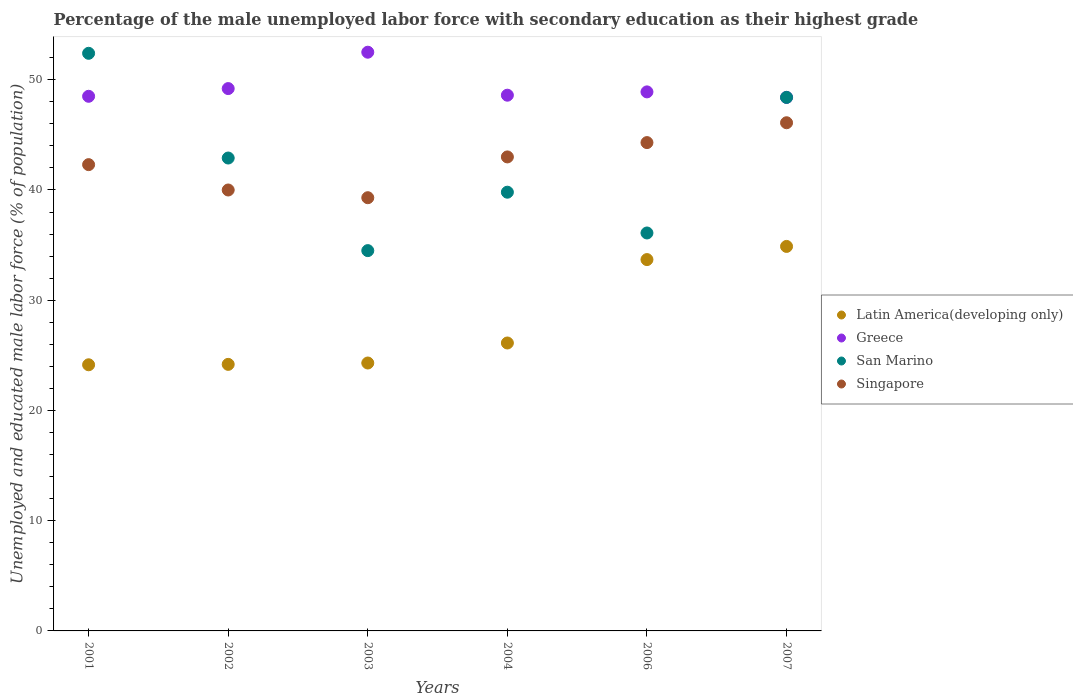Is the number of dotlines equal to the number of legend labels?
Provide a succinct answer. Yes. What is the percentage of the unemployed male labor force with secondary education in Latin America(developing only) in 2006?
Keep it short and to the point. 33.69. Across all years, what is the maximum percentage of the unemployed male labor force with secondary education in San Marino?
Keep it short and to the point. 52.4. Across all years, what is the minimum percentage of the unemployed male labor force with secondary education in Greece?
Your answer should be compact. 48.4. In which year was the percentage of the unemployed male labor force with secondary education in Singapore minimum?
Offer a terse response. 2003. What is the total percentage of the unemployed male labor force with secondary education in Latin America(developing only) in the graph?
Give a very brief answer. 167.32. What is the difference between the percentage of the unemployed male labor force with secondary education in San Marino in 2003 and that in 2007?
Your answer should be compact. -13.9. What is the difference between the percentage of the unemployed male labor force with secondary education in Singapore in 2006 and the percentage of the unemployed male labor force with secondary education in Greece in 2002?
Offer a terse response. -4.9. What is the average percentage of the unemployed male labor force with secondary education in San Marino per year?
Offer a terse response. 42.35. In the year 2007, what is the difference between the percentage of the unemployed male labor force with secondary education in Singapore and percentage of the unemployed male labor force with secondary education in San Marino?
Offer a very short reply. -2.3. What is the ratio of the percentage of the unemployed male labor force with secondary education in San Marino in 2003 to that in 2004?
Provide a short and direct response. 0.87. Is the percentage of the unemployed male labor force with secondary education in Singapore in 2004 less than that in 2007?
Your answer should be very brief. Yes. What is the difference between the highest and the second highest percentage of the unemployed male labor force with secondary education in Greece?
Your response must be concise. 3.3. What is the difference between the highest and the lowest percentage of the unemployed male labor force with secondary education in Latin America(developing only)?
Give a very brief answer. 10.74. In how many years, is the percentage of the unemployed male labor force with secondary education in Singapore greater than the average percentage of the unemployed male labor force with secondary education in Singapore taken over all years?
Your response must be concise. 3. Is the sum of the percentage of the unemployed male labor force with secondary education in Singapore in 2001 and 2006 greater than the maximum percentage of the unemployed male labor force with secondary education in Greece across all years?
Your answer should be compact. Yes. Is it the case that in every year, the sum of the percentage of the unemployed male labor force with secondary education in San Marino and percentage of the unemployed male labor force with secondary education in Singapore  is greater than the sum of percentage of the unemployed male labor force with secondary education in Latin America(developing only) and percentage of the unemployed male labor force with secondary education in Greece?
Your response must be concise. No. Is the percentage of the unemployed male labor force with secondary education in Singapore strictly greater than the percentage of the unemployed male labor force with secondary education in Greece over the years?
Keep it short and to the point. No. How many dotlines are there?
Your response must be concise. 4. Are the values on the major ticks of Y-axis written in scientific E-notation?
Your answer should be compact. No. Does the graph contain any zero values?
Your answer should be compact. No. Where does the legend appear in the graph?
Your answer should be very brief. Center right. How are the legend labels stacked?
Your answer should be very brief. Vertical. What is the title of the graph?
Your answer should be very brief. Percentage of the male unemployed labor force with secondary education as their highest grade. What is the label or title of the X-axis?
Offer a very short reply. Years. What is the label or title of the Y-axis?
Give a very brief answer. Unemployed and educated male labor force (% of population). What is the Unemployed and educated male labor force (% of population) of Latin America(developing only) in 2001?
Give a very brief answer. 24.14. What is the Unemployed and educated male labor force (% of population) of Greece in 2001?
Provide a short and direct response. 48.5. What is the Unemployed and educated male labor force (% of population) in San Marino in 2001?
Offer a very short reply. 52.4. What is the Unemployed and educated male labor force (% of population) of Singapore in 2001?
Provide a short and direct response. 42.3. What is the Unemployed and educated male labor force (% of population) of Latin America(developing only) in 2002?
Your answer should be compact. 24.18. What is the Unemployed and educated male labor force (% of population) in Greece in 2002?
Your answer should be very brief. 49.2. What is the Unemployed and educated male labor force (% of population) of San Marino in 2002?
Provide a succinct answer. 42.9. What is the Unemployed and educated male labor force (% of population) in Singapore in 2002?
Offer a terse response. 40. What is the Unemployed and educated male labor force (% of population) in Latin America(developing only) in 2003?
Your response must be concise. 24.3. What is the Unemployed and educated male labor force (% of population) in Greece in 2003?
Keep it short and to the point. 52.5. What is the Unemployed and educated male labor force (% of population) of San Marino in 2003?
Keep it short and to the point. 34.5. What is the Unemployed and educated male labor force (% of population) of Singapore in 2003?
Ensure brevity in your answer.  39.3. What is the Unemployed and educated male labor force (% of population) in Latin America(developing only) in 2004?
Ensure brevity in your answer.  26.12. What is the Unemployed and educated male labor force (% of population) in Greece in 2004?
Keep it short and to the point. 48.6. What is the Unemployed and educated male labor force (% of population) of San Marino in 2004?
Ensure brevity in your answer.  39.8. What is the Unemployed and educated male labor force (% of population) in Singapore in 2004?
Provide a succinct answer. 43. What is the Unemployed and educated male labor force (% of population) in Latin America(developing only) in 2006?
Offer a terse response. 33.69. What is the Unemployed and educated male labor force (% of population) of Greece in 2006?
Make the answer very short. 48.9. What is the Unemployed and educated male labor force (% of population) in San Marino in 2006?
Your answer should be very brief. 36.1. What is the Unemployed and educated male labor force (% of population) of Singapore in 2006?
Ensure brevity in your answer.  44.3. What is the Unemployed and educated male labor force (% of population) of Latin America(developing only) in 2007?
Offer a terse response. 34.88. What is the Unemployed and educated male labor force (% of population) of Greece in 2007?
Keep it short and to the point. 48.4. What is the Unemployed and educated male labor force (% of population) of San Marino in 2007?
Provide a short and direct response. 48.4. What is the Unemployed and educated male labor force (% of population) in Singapore in 2007?
Your response must be concise. 46.1. Across all years, what is the maximum Unemployed and educated male labor force (% of population) of Latin America(developing only)?
Keep it short and to the point. 34.88. Across all years, what is the maximum Unemployed and educated male labor force (% of population) in Greece?
Keep it short and to the point. 52.5. Across all years, what is the maximum Unemployed and educated male labor force (% of population) in San Marino?
Your response must be concise. 52.4. Across all years, what is the maximum Unemployed and educated male labor force (% of population) of Singapore?
Ensure brevity in your answer.  46.1. Across all years, what is the minimum Unemployed and educated male labor force (% of population) in Latin America(developing only)?
Your answer should be compact. 24.14. Across all years, what is the minimum Unemployed and educated male labor force (% of population) of Greece?
Your response must be concise. 48.4. Across all years, what is the minimum Unemployed and educated male labor force (% of population) of San Marino?
Your answer should be very brief. 34.5. Across all years, what is the minimum Unemployed and educated male labor force (% of population) of Singapore?
Offer a very short reply. 39.3. What is the total Unemployed and educated male labor force (% of population) in Latin America(developing only) in the graph?
Keep it short and to the point. 167.32. What is the total Unemployed and educated male labor force (% of population) of Greece in the graph?
Your response must be concise. 296.1. What is the total Unemployed and educated male labor force (% of population) in San Marino in the graph?
Your response must be concise. 254.1. What is the total Unemployed and educated male labor force (% of population) in Singapore in the graph?
Your answer should be compact. 255. What is the difference between the Unemployed and educated male labor force (% of population) in Latin America(developing only) in 2001 and that in 2002?
Ensure brevity in your answer.  -0.04. What is the difference between the Unemployed and educated male labor force (% of population) of Greece in 2001 and that in 2002?
Ensure brevity in your answer.  -0.7. What is the difference between the Unemployed and educated male labor force (% of population) of Singapore in 2001 and that in 2002?
Give a very brief answer. 2.3. What is the difference between the Unemployed and educated male labor force (% of population) in Latin America(developing only) in 2001 and that in 2003?
Offer a very short reply. -0.16. What is the difference between the Unemployed and educated male labor force (% of population) in Greece in 2001 and that in 2003?
Keep it short and to the point. -4. What is the difference between the Unemployed and educated male labor force (% of population) of San Marino in 2001 and that in 2003?
Give a very brief answer. 17.9. What is the difference between the Unemployed and educated male labor force (% of population) in Singapore in 2001 and that in 2003?
Your answer should be very brief. 3. What is the difference between the Unemployed and educated male labor force (% of population) in Latin America(developing only) in 2001 and that in 2004?
Offer a terse response. -1.98. What is the difference between the Unemployed and educated male labor force (% of population) of Greece in 2001 and that in 2004?
Offer a very short reply. -0.1. What is the difference between the Unemployed and educated male labor force (% of population) of San Marino in 2001 and that in 2004?
Provide a succinct answer. 12.6. What is the difference between the Unemployed and educated male labor force (% of population) in Singapore in 2001 and that in 2004?
Give a very brief answer. -0.7. What is the difference between the Unemployed and educated male labor force (% of population) in Latin America(developing only) in 2001 and that in 2006?
Your answer should be compact. -9.54. What is the difference between the Unemployed and educated male labor force (% of population) in Greece in 2001 and that in 2006?
Ensure brevity in your answer.  -0.4. What is the difference between the Unemployed and educated male labor force (% of population) in Latin America(developing only) in 2001 and that in 2007?
Keep it short and to the point. -10.74. What is the difference between the Unemployed and educated male labor force (% of population) of Greece in 2001 and that in 2007?
Provide a succinct answer. 0.1. What is the difference between the Unemployed and educated male labor force (% of population) of San Marino in 2001 and that in 2007?
Offer a very short reply. 4. What is the difference between the Unemployed and educated male labor force (% of population) in Singapore in 2001 and that in 2007?
Ensure brevity in your answer.  -3.8. What is the difference between the Unemployed and educated male labor force (% of population) in Latin America(developing only) in 2002 and that in 2003?
Offer a very short reply. -0.12. What is the difference between the Unemployed and educated male labor force (% of population) of Singapore in 2002 and that in 2003?
Your answer should be compact. 0.7. What is the difference between the Unemployed and educated male labor force (% of population) of Latin America(developing only) in 2002 and that in 2004?
Your answer should be compact. -1.94. What is the difference between the Unemployed and educated male labor force (% of population) in San Marino in 2002 and that in 2004?
Your answer should be compact. 3.1. What is the difference between the Unemployed and educated male labor force (% of population) in Latin America(developing only) in 2002 and that in 2006?
Provide a succinct answer. -9.51. What is the difference between the Unemployed and educated male labor force (% of population) of Greece in 2002 and that in 2006?
Make the answer very short. 0.3. What is the difference between the Unemployed and educated male labor force (% of population) of Latin America(developing only) in 2002 and that in 2007?
Your answer should be very brief. -10.7. What is the difference between the Unemployed and educated male labor force (% of population) in Latin America(developing only) in 2003 and that in 2004?
Keep it short and to the point. -1.82. What is the difference between the Unemployed and educated male labor force (% of population) in Latin America(developing only) in 2003 and that in 2006?
Offer a very short reply. -9.38. What is the difference between the Unemployed and educated male labor force (% of population) of Singapore in 2003 and that in 2006?
Offer a terse response. -5. What is the difference between the Unemployed and educated male labor force (% of population) of Latin America(developing only) in 2003 and that in 2007?
Give a very brief answer. -10.58. What is the difference between the Unemployed and educated male labor force (% of population) in Latin America(developing only) in 2004 and that in 2006?
Your answer should be compact. -7.57. What is the difference between the Unemployed and educated male labor force (% of population) of Greece in 2004 and that in 2006?
Your answer should be compact. -0.3. What is the difference between the Unemployed and educated male labor force (% of population) in Singapore in 2004 and that in 2006?
Give a very brief answer. -1.3. What is the difference between the Unemployed and educated male labor force (% of population) of Latin America(developing only) in 2004 and that in 2007?
Your answer should be very brief. -8.76. What is the difference between the Unemployed and educated male labor force (% of population) in San Marino in 2004 and that in 2007?
Keep it short and to the point. -8.6. What is the difference between the Unemployed and educated male labor force (% of population) in Singapore in 2004 and that in 2007?
Your answer should be very brief. -3.1. What is the difference between the Unemployed and educated male labor force (% of population) in Latin America(developing only) in 2006 and that in 2007?
Make the answer very short. -1.19. What is the difference between the Unemployed and educated male labor force (% of population) in Greece in 2006 and that in 2007?
Your response must be concise. 0.5. What is the difference between the Unemployed and educated male labor force (% of population) in San Marino in 2006 and that in 2007?
Offer a very short reply. -12.3. What is the difference between the Unemployed and educated male labor force (% of population) in Singapore in 2006 and that in 2007?
Your response must be concise. -1.8. What is the difference between the Unemployed and educated male labor force (% of population) of Latin America(developing only) in 2001 and the Unemployed and educated male labor force (% of population) of Greece in 2002?
Provide a short and direct response. -25.06. What is the difference between the Unemployed and educated male labor force (% of population) in Latin America(developing only) in 2001 and the Unemployed and educated male labor force (% of population) in San Marino in 2002?
Offer a terse response. -18.76. What is the difference between the Unemployed and educated male labor force (% of population) in Latin America(developing only) in 2001 and the Unemployed and educated male labor force (% of population) in Singapore in 2002?
Make the answer very short. -15.86. What is the difference between the Unemployed and educated male labor force (% of population) in Latin America(developing only) in 2001 and the Unemployed and educated male labor force (% of population) in Greece in 2003?
Provide a succinct answer. -28.36. What is the difference between the Unemployed and educated male labor force (% of population) in Latin America(developing only) in 2001 and the Unemployed and educated male labor force (% of population) in San Marino in 2003?
Your response must be concise. -10.36. What is the difference between the Unemployed and educated male labor force (% of population) of Latin America(developing only) in 2001 and the Unemployed and educated male labor force (% of population) of Singapore in 2003?
Provide a short and direct response. -15.16. What is the difference between the Unemployed and educated male labor force (% of population) of Greece in 2001 and the Unemployed and educated male labor force (% of population) of San Marino in 2003?
Provide a short and direct response. 14. What is the difference between the Unemployed and educated male labor force (% of population) in Latin America(developing only) in 2001 and the Unemployed and educated male labor force (% of population) in Greece in 2004?
Keep it short and to the point. -24.46. What is the difference between the Unemployed and educated male labor force (% of population) of Latin America(developing only) in 2001 and the Unemployed and educated male labor force (% of population) of San Marino in 2004?
Your answer should be very brief. -15.66. What is the difference between the Unemployed and educated male labor force (% of population) in Latin America(developing only) in 2001 and the Unemployed and educated male labor force (% of population) in Singapore in 2004?
Give a very brief answer. -18.86. What is the difference between the Unemployed and educated male labor force (% of population) in Latin America(developing only) in 2001 and the Unemployed and educated male labor force (% of population) in Greece in 2006?
Make the answer very short. -24.76. What is the difference between the Unemployed and educated male labor force (% of population) of Latin America(developing only) in 2001 and the Unemployed and educated male labor force (% of population) of San Marino in 2006?
Offer a very short reply. -11.96. What is the difference between the Unemployed and educated male labor force (% of population) of Latin America(developing only) in 2001 and the Unemployed and educated male labor force (% of population) of Singapore in 2006?
Your answer should be compact. -20.16. What is the difference between the Unemployed and educated male labor force (% of population) in Greece in 2001 and the Unemployed and educated male labor force (% of population) in San Marino in 2006?
Ensure brevity in your answer.  12.4. What is the difference between the Unemployed and educated male labor force (% of population) of San Marino in 2001 and the Unemployed and educated male labor force (% of population) of Singapore in 2006?
Keep it short and to the point. 8.1. What is the difference between the Unemployed and educated male labor force (% of population) in Latin America(developing only) in 2001 and the Unemployed and educated male labor force (% of population) in Greece in 2007?
Offer a terse response. -24.26. What is the difference between the Unemployed and educated male labor force (% of population) of Latin America(developing only) in 2001 and the Unemployed and educated male labor force (% of population) of San Marino in 2007?
Provide a succinct answer. -24.26. What is the difference between the Unemployed and educated male labor force (% of population) of Latin America(developing only) in 2001 and the Unemployed and educated male labor force (% of population) of Singapore in 2007?
Ensure brevity in your answer.  -21.96. What is the difference between the Unemployed and educated male labor force (% of population) in Latin America(developing only) in 2002 and the Unemployed and educated male labor force (% of population) in Greece in 2003?
Provide a succinct answer. -28.32. What is the difference between the Unemployed and educated male labor force (% of population) in Latin America(developing only) in 2002 and the Unemployed and educated male labor force (% of population) in San Marino in 2003?
Provide a succinct answer. -10.32. What is the difference between the Unemployed and educated male labor force (% of population) in Latin America(developing only) in 2002 and the Unemployed and educated male labor force (% of population) in Singapore in 2003?
Give a very brief answer. -15.12. What is the difference between the Unemployed and educated male labor force (% of population) of Greece in 2002 and the Unemployed and educated male labor force (% of population) of Singapore in 2003?
Provide a short and direct response. 9.9. What is the difference between the Unemployed and educated male labor force (% of population) in San Marino in 2002 and the Unemployed and educated male labor force (% of population) in Singapore in 2003?
Provide a short and direct response. 3.6. What is the difference between the Unemployed and educated male labor force (% of population) in Latin America(developing only) in 2002 and the Unemployed and educated male labor force (% of population) in Greece in 2004?
Your response must be concise. -24.42. What is the difference between the Unemployed and educated male labor force (% of population) of Latin America(developing only) in 2002 and the Unemployed and educated male labor force (% of population) of San Marino in 2004?
Your answer should be very brief. -15.62. What is the difference between the Unemployed and educated male labor force (% of population) of Latin America(developing only) in 2002 and the Unemployed and educated male labor force (% of population) of Singapore in 2004?
Keep it short and to the point. -18.82. What is the difference between the Unemployed and educated male labor force (% of population) of Greece in 2002 and the Unemployed and educated male labor force (% of population) of San Marino in 2004?
Give a very brief answer. 9.4. What is the difference between the Unemployed and educated male labor force (% of population) of Greece in 2002 and the Unemployed and educated male labor force (% of population) of Singapore in 2004?
Your answer should be compact. 6.2. What is the difference between the Unemployed and educated male labor force (% of population) of Latin America(developing only) in 2002 and the Unemployed and educated male labor force (% of population) of Greece in 2006?
Provide a short and direct response. -24.72. What is the difference between the Unemployed and educated male labor force (% of population) of Latin America(developing only) in 2002 and the Unemployed and educated male labor force (% of population) of San Marino in 2006?
Provide a short and direct response. -11.92. What is the difference between the Unemployed and educated male labor force (% of population) in Latin America(developing only) in 2002 and the Unemployed and educated male labor force (% of population) in Singapore in 2006?
Offer a very short reply. -20.12. What is the difference between the Unemployed and educated male labor force (% of population) of San Marino in 2002 and the Unemployed and educated male labor force (% of population) of Singapore in 2006?
Offer a terse response. -1.4. What is the difference between the Unemployed and educated male labor force (% of population) of Latin America(developing only) in 2002 and the Unemployed and educated male labor force (% of population) of Greece in 2007?
Provide a succinct answer. -24.22. What is the difference between the Unemployed and educated male labor force (% of population) in Latin America(developing only) in 2002 and the Unemployed and educated male labor force (% of population) in San Marino in 2007?
Your answer should be compact. -24.22. What is the difference between the Unemployed and educated male labor force (% of population) of Latin America(developing only) in 2002 and the Unemployed and educated male labor force (% of population) of Singapore in 2007?
Your answer should be very brief. -21.92. What is the difference between the Unemployed and educated male labor force (% of population) of Greece in 2002 and the Unemployed and educated male labor force (% of population) of San Marino in 2007?
Provide a succinct answer. 0.8. What is the difference between the Unemployed and educated male labor force (% of population) of Greece in 2002 and the Unemployed and educated male labor force (% of population) of Singapore in 2007?
Your response must be concise. 3.1. What is the difference between the Unemployed and educated male labor force (% of population) of San Marino in 2002 and the Unemployed and educated male labor force (% of population) of Singapore in 2007?
Give a very brief answer. -3.2. What is the difference between the Unemployed and educated male labor force (% of population) in Latin America(developing only) in 2003 and the Unemployed and educated male labor force (% of population) in Greece in 2004?
Keep it short and to the point. -24.3. What is the difference between the Unemployed and educated male labor force (% of population) in Latin America(developing only) in 2003 and the Unemployed and educated male labor force (% of population) in San Marino in 2004?
Your response must be concise. -15.5. What is the difference between the Unemployed and educated male labor force (% of population) in Latin America(developing only) in 2003 and the Unemployed and educated male labor force (% of population) in Singapore in 2004?
Your response must be concise. -18.7. What is the difference between the Unemployed and educated male labor force (% of population) in Greece in 2003 and the Unemployed and educated male labor force (% of population) in San Marino in 2004?
Provide a short and direct response. 12.7. What is the difference between the Unemployed and educated male labor force (% of population) of San Marino in 2003 and the Unemployed and educated male labor force (% of population) of Singapore in 2004?
Your answer should be compact. -8.5. What is the difference between the Unemployed and educated male labor force (% of population) in Latin America(developing only) in 2003 and the Unemployed and educated male labor force (% of population) in Greece in 2006?
Ensure brevity in your answer.  -24.6. What is the difference between the Unemployed and educated male labor force (% of population) of Latin America(developing only) in 2003 and the Unemployed and educated male labor force (% of population) of San Marino in 2006?
Offer a very short reply. -11.8. What is the difference between the Unemployed and educated male labor force (% of population) of Latin America(developing only) in 2003 and the Unemployed and educated male labor force (% of population) of Singapore in 2006?
Ensure brevity in your answer.  -20. What is the difference between the Unemployed and educated male labor force (% of population) of Greece in 2003 and the Unemployed and educated male labor force (% of population) of San Marino in 2006?
Your answer should be very brief. 16.4. What is the difference between the Unemployed and educated male labor force (% of population) in Greece in 2003 and the Unemployed and educated male labor force (% of population) in Singapore in 2006?
Make the answer very short. 8.2. What is the difference between the Unemployed and educated male labor force (% of population) in Latin America(developing only) in 2003 and the Unemployed and educated male labor force (% of population) in Greece in 2007?
Your answer should be compact. -24.1. What is the difference between the Unemployed and educated male labor force (% of population) in Latin America(developing only) in 2003 and the Unemployed and educated male labor force (% of population) in San Marino in 2007?
Provide a short and direct response. -24.1. What is the difference between the Unemployed and educated male labor force (% of population) of Latin America(developing only) in 2003 and the Unemployed and educated male labor force (% of population) of Singapore in 2007?
Make the answer very short. -21.8. What is the difference between the Unemployed and educated male labor force (% of population) in Greece in 2003 and the Unemployed and educated male labor force (% of population) in San Marino in 2007?
Give a very brief answer. 4.1. What is the difference between the Unemployed and educated male labor force (% of population) of San Marino in 2003 and the Unemployed and educated male labor force (% of population) of Singapore in 2007?
Give a very brief answer. -11.6. What is the difference between the Unemployed and educated male labor force (% of population) of Latin America(developing only) in 2004 and the Unemployed and educated male labor force (% of population) of Greece in 2006?
Provide a succinct answer. -22.78. What is the difference between the Unemployed and educated male labor force (% of population) in Latin America(developing only) in 2004 and the Unemployed and educated male labor force (% of population) in San Marino in 2006?
Make the answer very short. -9.98. What is the difference between the Unemployed and educated male labor force (% of population) in Latin America(developing only) in 2004 and the Unemployed and educated male labor force (% of population) in Singapore in 2006?
Give a very brief answer. -18.18. What is the difference between the Unemployed and educated male labor force (% of population) of Greece in 2004 and the Unemployed and educated male labor force (% of population) of San Marino in 2006?
Provide a short and direct response. 12.5. What is the difference between the Unemployed and educated male labor force (% of population) of Greece in 2004 and the Unemployed and educated male labor force (% of population) of Singapore in 2006?
Give a very brief answer. 4.3. What is the difference between the Unemployed and educated male labor force (% of population) of Latin America(developing only) in 2004 and the Unemployed and educated male labor force (% of population) of Greece in 2007?
Your answer should be compact. -22.28. What is the difference between the Unemployed and educated male labor force (% of population) of Latin America(developing only) in 2004 and the Unemployed and educated male labor force (% of population) of San Marino in 2007?
Keep it short and to the point. -22.28. What is the difference between the Unemployed and educated male labor force (% of population) of Latin America(developing only) in 2004 and the Unemployed and educated male labor force (% of population) of Singapore in 2007?
Ensure brevity in your answer.  -19.98. What is the difference between the Unemployed and educated male labor force (% of population) of Greece in 2004 and the Unemployed and educated male labor force (% of population) of San Marino in 2007?
Your response must be concise. 0.2. What is the difference between the Unemployed and educated male labor force (% of population) in San Marino in 2004 and the Unemployed and educated male labor force (% of population) in Singapore in 2007?
Provide a succinct answer. -6.3. What is the difference between the Unemployed and educated male labor force (% of population) in Latin America(developing only) in 2006 and the Unemployed and educated male labor force (% of population) in Greece in 2007?
Make the answer very short. -14.71. What is the difference between the Unemployed and educated male labor force (% of population) of Latin America(developing only) in 2006 and the Unemployed and educated male labor force (% of population) of San Marino in 2007?
Ensure brevity in your answer.  -14.71. What is the difference between the Unemployed and educated male labor force (% of population) in Latin America(developing only) in 2006 and the Unemployed and educated male labor force (% of population) in Singapore in 2007?
Make the answer very short. -12.41. What is the difference between the Unemployed and educated male labor force (% of population) in Greece in 2006 and the Unemployed and educated male labor force (% of population) in San Marino in 2007?
Offer a terse response. 0.5. What is the difference between the Unemployed and educated male labor force (% of population) of San Marino in 2006 and the Unemployed and educated male labor force (% of population) of Singapore in 2007?
Give a very brief answer. -10. What is the average Unemployed and educated male labor force (% of population) of Latin America(developing only) per year?
Your answer should be compact. 27.89. What is the average Unemployed and educated male labor force (% of population) in Greece per year?
Your answer should be compact. 49.35. What is the average Unemployed and educated male labor force (% of population) of San Marino per year?
Offer a terse response. 42.35. What is the average Unemployed and educated male labor force (% of population) of Singapore per year?
Give a very brief answer. 42.5. In the year 2001, what is the difference between the Unemployed and educated male labor force (% of population) in Latin America(developing only) and Unemployed and educated male labor force (% of population) in Greece?
Make the answer very short. -24.36. In the year 2001, what is the difference between the Unemployed and educated male labor force (% of population) of Latin America(developing only) and Unemployed and educated male labor force (% of population) of San Marino?
Provide a short and direct response. -28.26. In the year 2001, what is the difference between the Unemployed and educated male labor force (% of population) in Latin America(developing only) and Unemployed and educated male labor force (% of population) in Singapore?
Provide a short and direct response. -18.16. In the year 2001, what is the difference between the Unemployed and educated male labor force (% of population) in Greece and Unemployed and educated male labor force (% of population) in Singapore?
Keep it short and to the point. 6.2. In the year 2002, what is the difference between the Unemployed and educated male labor force (% of population) in Latin America(developing only) and Unemployed and educated male labor force (% of population) in Greece?
Offer a terse response. -25.02. In the year 2002, what is the difference between the Unemployed and educated male labor force (% of population) of Latin America(developing only) and Unemployed and educated male labor force (% of population) of San Marino?
Provide a short and direct response. -18.72. In the year 2002, what is the difference between the Unemployed and educated male labor force (% of population) of Latin America(developing only) and Unemployed and educated male labor force (% of population) of Singapore?
Give a very brief answer. -15.82. In the year 2002, what is the difference between the Unemployed and educated male labor force (% of population) in Greece and Unemployed and educated male labor force (% of population) in San Marino?
Ensure brevity in your answer.  6.3. In the year 2002, what is the difference between the Unemployed and educated male labor force (% of population) in Greece and Unemployed and educated male labor force (% of population) in Singapore?
Offer a very short reply. 9.2. In the year 2002, what is the difference between the Unemployed and educated male labor force (% of population) in San Marino and Unemployed and educated male labor force (% of population) in Singapore?
Make the answer very short. 2.9. In the year 2003, what is the difference between the Unemployed and educated male labor force (% of population) of Latin America(developing only) and Unemployed and educated male labor force (% of population) of Greece?
Make the answer very short. -28.2. In the year 2003, what is the difference between the Unemployed and educated male labor force (% of population) of Latin America(developing only) and Unemployed and educated male labor force (% of population) of San Marino?
Offer a terse response. -10.2. In the year 2003, what is the difference between the Unemployed and educated male labor force (% of population) in Latin America(developing only) and Unemployed and educated male labor force (% of population) in Singapore?
Your answer should be compact. -15. In the year 2003, what is the difference between the Unemployed and educated male labor force (% of population) of Greece and Unemployed and educated male labor force (% of population) of Singapore?
Make the answer very short. 13.2. In the year 2003, what is the difference between the Unemployed and educated male labor force (% of population) of San Marino and Unemployed and educated male labor force (% of population) of Singapore?
Your response must be concise. -4.8. In the year 2004, what is the difference between the Unemployed and educated male labor force (% of population) of Latin America(developing only) and Unemployed and educated male labor force (% of population) of Greece?
Your answer should be very brief. -22.48. In the year 2004, what is the difference between the Unemployed and educated male labor force (% of population) in Latin America(developing only) and Unemployed and educated male labor force (% of population) in San Marino?
Keep it short and to the point. -13.68. In the year 2004, what is the difference between the Unemployed and educated male labor force (% of population) of Latin America(developing only) and Unemployed and educated male labor force (% of population) of Singapore?
Provide a succinct answer. -16.88. In the year 2004, what is the difference between the Unemployed and educated male labor force (% of population) in Greece and Unemployed and educated male labor force (% of population) in San Marino?
Provide a succinct answer. 8.8. In the year 2004, what is the difference between the Unemployed and educated male labor force (% of population) in San Marino and Unemployed and educated male labor force (% of population) in Singapore?
Keep it short and to the point. -3.2. In the year 2006, what is the difference between the Unemployed and educated male labor force (% of population) in Latin America(developing only) and Unemployed and educated male labor force (% of population) in Greece?
Provide a short and direct response. -15.21. In the year 2006, what is the difference between the Unemployed and educated male labor force (% of population) in Latin America(developing only) and Unemployed and educated male labor force (% of population) in San Marino?
Keep it short and to the point. -2.41. In the year 2006, what is the difference between the Unemployed and educated male labor force (% of population) in Latin America(developing only) and Unemployed and educated male labor force (% of population) in Singapore?
Give a very brief answer. -10.61. In the year 2006, what is the difference between the Unemployed and educated male labor force (% of population) of Greece and Unemployed and educated male labor force (% of population) of San Marino?
Your answer should be compact. 12.8. In the year 2006, what is the difference between the Unemployed and educated male labor force (% of population) in Greece and Unemployed and educated male labor force (% of population) in Singapore?
Keep it short and to the point. 4.6. In the year 2006, what is the difference between the Unemployed and educated male labor force (% of population) in San Marino and Unemployed and educated male labor force (% of population) in Singapore?
Your answer should be very brief. -8.2. In the year 2007, what is the difference between the Unemployed and educated male labor force (% of population) of Latin America(developing only) and Unemployed and educated male labor force (% of population) of Greece?
Offer a very short reply. -13.52. In the year 2007, what is the difference between the Unemployed and educated male labor force (% of population) of Latin America(developing only) and Unemployed and educated male labor force (% of population) of San Marino?
Your answer should be compact. -13.52. In the year 2007, what is the difference between the Unemployed and educated male labor force (% of population) of Latin America(developing only) and Unemployed and educated male labor force (% of population) of Singapore?
Keep it short and to the point. -11.22. In the year 2007, what is the difference between the Unemployed and educated male labor force (% of population) in Greece and Unemployed and educated male labor force (% of population) in Singapore?
Give a very brief answer. 2.3. What is the ratio of the Unemployed and educated male labor force (% of population) of Greece in 2001 to that in 2002?
Ensure brevity in your answer.  0.99. What is the ratio of the Unemployed and educated male labor force (% of population) of San Marino in 2001 to that in 2002?
Your answer should be very brief. 1.22. What is the ratio of the Unemployed and educated male labor force (% of population) in Singapore in 2001 to that in 2002?
Offer a very short reply. 1.06. What is the ratio of the Unemployed and educated male labor force (% of population) in Latin America(developing only) in 2001 to that in 2003?
Give a very brief answer. 0.99. What is the ratio of the Unemployed and educated male labor force (% of population) in Greece in 2001 to that in 2003?
Offer a terse response. 0.92. What is the ratio of the Unemployed and educated male labor force (% of population) of San Marino in 2001 to that in 2003?
Your answer should be very brief. 1.52. What is the ratio of the Unemployed and educated male labor force (% of population) of Singapore in 2001 to that in 2003?
Your answer should be very brief. 1.08. What is the ratio of the Unemployed and educated male labor force (% of population) in Latin America(developing only) in 2001 to that in 2004?
Offer a terse response. 0.92. What is the ratio of the Unemployed and educated male labor force (% of population) of San Marino in 2001 to that in 2004?
Your answer should be compact. 1.32. What is the ratio of the Unemployed and educated male labor force (% of population) of Singapore in 2001 to that in 2004?
Ensure brevity in your answer.  0.98. What is the ratio of the Unemployed and educated male labor force (% of population) of Latin America(developing only) in 2001 to that in 2006?
Offer a very short reply. 0.72. What is the ratio of the Unemployed and educated male labor force (% of population) in Greece in 2001 to that in 2006?
Ensure brevity in your answer.  0.99. What is the ratio of the Unemployed and educated male labor force (% of population) in San Marino in 2001 to that in 2006?
Your response must be concise. 1.45. What is the ratio of the Unemployed and educated male labor force (% of population) in Singapore in 2001 to that in 2006?
Offer a very short reply. 0.95. What is the ratio of the Unemployed and educated male labor force (% of population) of Latin America(developing only) in 2001 to that in 2007?
Make the answer very short. 0.69. What is the ratio of the Unemployed and educated male labor force (% of population) in Greece in 2001 to that in 2007?
Make the answer very short. 1. What is the ratio of the Unemployed and educated male labor force (% of population) of San Marino in 2001 to that in 2007?
Your answer should be compact. 1.08. What is the ratio of the Unemployed and educated male labor force (% of population) of Singapore in 2001 to that in 2007?
Your answer should be compact. 0.92. What is the ratio of the Unemployed and educated male labor force (% of population) in Latin America(developing only) in 2002 to that in 2003?
Your answer should be compact. 0.99. What is the ratio of the Unemployed and educated male labor force (% of population) in Greece in 2002 to that in 2003?
Your response must be concise. 0.94. What is the ratio of the Unemployed and educated male labor force (% of population) of San Marino in 2002 to that in 2003?
Provide a short and direct response. 1.24. What is the ratio of the Unemployed and educated male labor force (% of population) of Singapore in 2002 to that in 2003?
Ensure brevity in your answer.  1.02. What is the ratio of the Unemployed and educated male labor force (% of population) of Latin America(developing only) in 2002 to that in 2004?
Your answer should be compact. 0.93. What is the ratio of the Unemployed and educated male labor force (% of population) of Greece in 2002 to that in 2004?
Your answer should be compact. 1.01. What is the ratio of the Unemployed and educated male labor force (% of population) in San Marino in 2002 to that in 2004?
Your answer should be compact. 1.08. What is the ratio of the Unemployed and educated male labor force (% of population) in Singapore in 2002 to that in 2004?
Provide a succinct answer. 0.93. What is the ratio of the Unemployed and educated male labor force (% of population) in Latin America(developing only) in 2002 to that in 2006?
Provide a succinct answer. 0.72. What is the ratio of the Unemployed and educated male labor force (% of population) of San Marino in 2002 to that in 2006?
Keep it short and to the point. 1.19. What is the ratio of the Unemployed and educated male labor force (% of population) of Singapore in 2002 to that in 2006?
Offer a terse response. 0.9. What is the ratio of the Unemployed and educated male labor force (% of population) in Latin America(developing only) in 2002 to that in 2007?
Provide a short and direct response. 0.69. What is the ratio of the Unemployed and educated male labor force (% of population) in Greece in 2002 to that in 2007?
Provide a succinct answer. 1.02. What is the ratio of the Unemployed and educated male labor force (% of population) in San Marino in 2002 to that in 2007?
Provide a short and direct response. 0.89. What is the ratio of the Unemployed and educated male labor force (% of population) of Singapore in 2002 to that in 2007?
Offer a terse response. 0.87. What is the ratio of the Unemployed and educated male labor force (% of population) in Latin America(developing only) in 2003 to that in 2004?
Your response must be concise. 0.93. What is the ratio of the Unemployed and educated male labor force (% of population) in Greece in 2003 to that in 2004?
Give a very brief answer. 1.08. What is the ratio of the Unemployed and educated male labor force (% of population) in San Marino in 2003 to that in 2004?
Provide a short and direct response. 0.87. What is the ratio of the Unemployed and educated male labor force (% of population) of Singapore in 2003 to that in 2004?
Your answer should be very brief. 0.91. What is the ratio of the Unemployed and educated male labor force (% of population) of Latin America(developing only) in 2003 to that in 2006?
Make the answer very short. 0.72. What is the ratio of the Unemployed and educated male labor force (% of population) of Greece in 2003 to that in 2006?
Offer a terse response. 1.07. What is the ratio of the Unemployed and educated male labor force (% of population) of San Marino in 2003 to that in 2006?
Keep it short and to the point. 0.96. What is the ratio of the Unemployed and educated male labor force (% of population) in Singapore in 2003 to that in 2006?
Keep it short and to the point. 0.89. What is the ratio of the Unemployed and educated male labor force (% of population) in Latin America(developing only) in 2003 to that in 2007?
Your response must be concise. 0.7. What is the ratio of the Unemployed and educated male labor force (% of population) of Greece in 2003 to that in 2007?
Give a very brief answer. 1.08. What is the ratio of the Unemployed and educated male labor force (% of population) in San Marino in 2003 to that in 2007?
Make the answer very short. 0.71. What is the ratio of the Unemployed and educated male labor force (% of population) of Singapore in 2003 to that in 2007?
Your response must be concise. 0.85. What is the ratio of the Unemployed and educated male labor force (% of population) in Latin America(developing only) in 2004 to that in 2006?
Offer a very short reply. 0.78. What is the ratio of the Unemployed and educated male labor force (% of population) in Greece in 2004 to that in 2006?
Offer a terse response. 0.99. What is the ratio of the Unemployed and educated male labor force (% of population) in San Marino in 2004 to that in 2006?
Provide a short and direct response. 1.1. What is the ratio of the Unemployed and educated male labor force (% of population) in Singapore in 2004 to that in 2006?
Make the answer very short. 0.97. What is the ratio of the Unemployed and educated male labor force (% of population) in Latin America(developing only) in 2004 to that in 2007?
Your answer should be very brief. 0.75. What is the ratio of the Unemployed and educated male labor force (% of population) of San Marino in 2004 to that in 2007?
Your answer should be very brief. 0.82. What is the ratio of the Unemployed and educated male labor force (% of population) in Singapore in 2004 to that in 2007?
Provide a succinct answer. 0.93. What is the ratio of the Unemployed and educated male labor force (% of population) in Latin America(developing only) in 2006 to that in 2007?
Provide a succinct answer. 0.97. What is the ratio of the Unemployed and educated male labor force (% of population) in Greece in 2006 to that in 2007?
Make the answer very short. 1.01. What is the ratio of the Unemployed and educated male labor force (% of population) in San Marino in 2006 to that in 2007?
Give a very brief answer. 0.75. What is the ratio of the Unemployed and educated male labor force (% of population) in Singapore in 2006 to that in 2007?
Provide a short and direct response. 0.96. What is the difference between the highest and the second highest Unemployed and educated male labor force (% of population) in Latin America(developing only)?
Provide a succinct answer. 1.19. What is the difference between the highest and the second highest Unemployed and educated male labor force (% of population) of Greece?
Make the answer very short. 3.3. What is the difference between the highest and the second highest Unemployed and educated male labor force (% of population) of San Marino?
Give a very brief answer. 4. What is the difference between the highest and the lowest Unemployed and educated male labor force (% of population) of Latin America(developing only)?
Make the answer very short. 10.74. What is the difference between the highest and the lowest Unemployed and educated male labor force (% of population) in San Marino?
Keep it short and to the point. 17.9. 